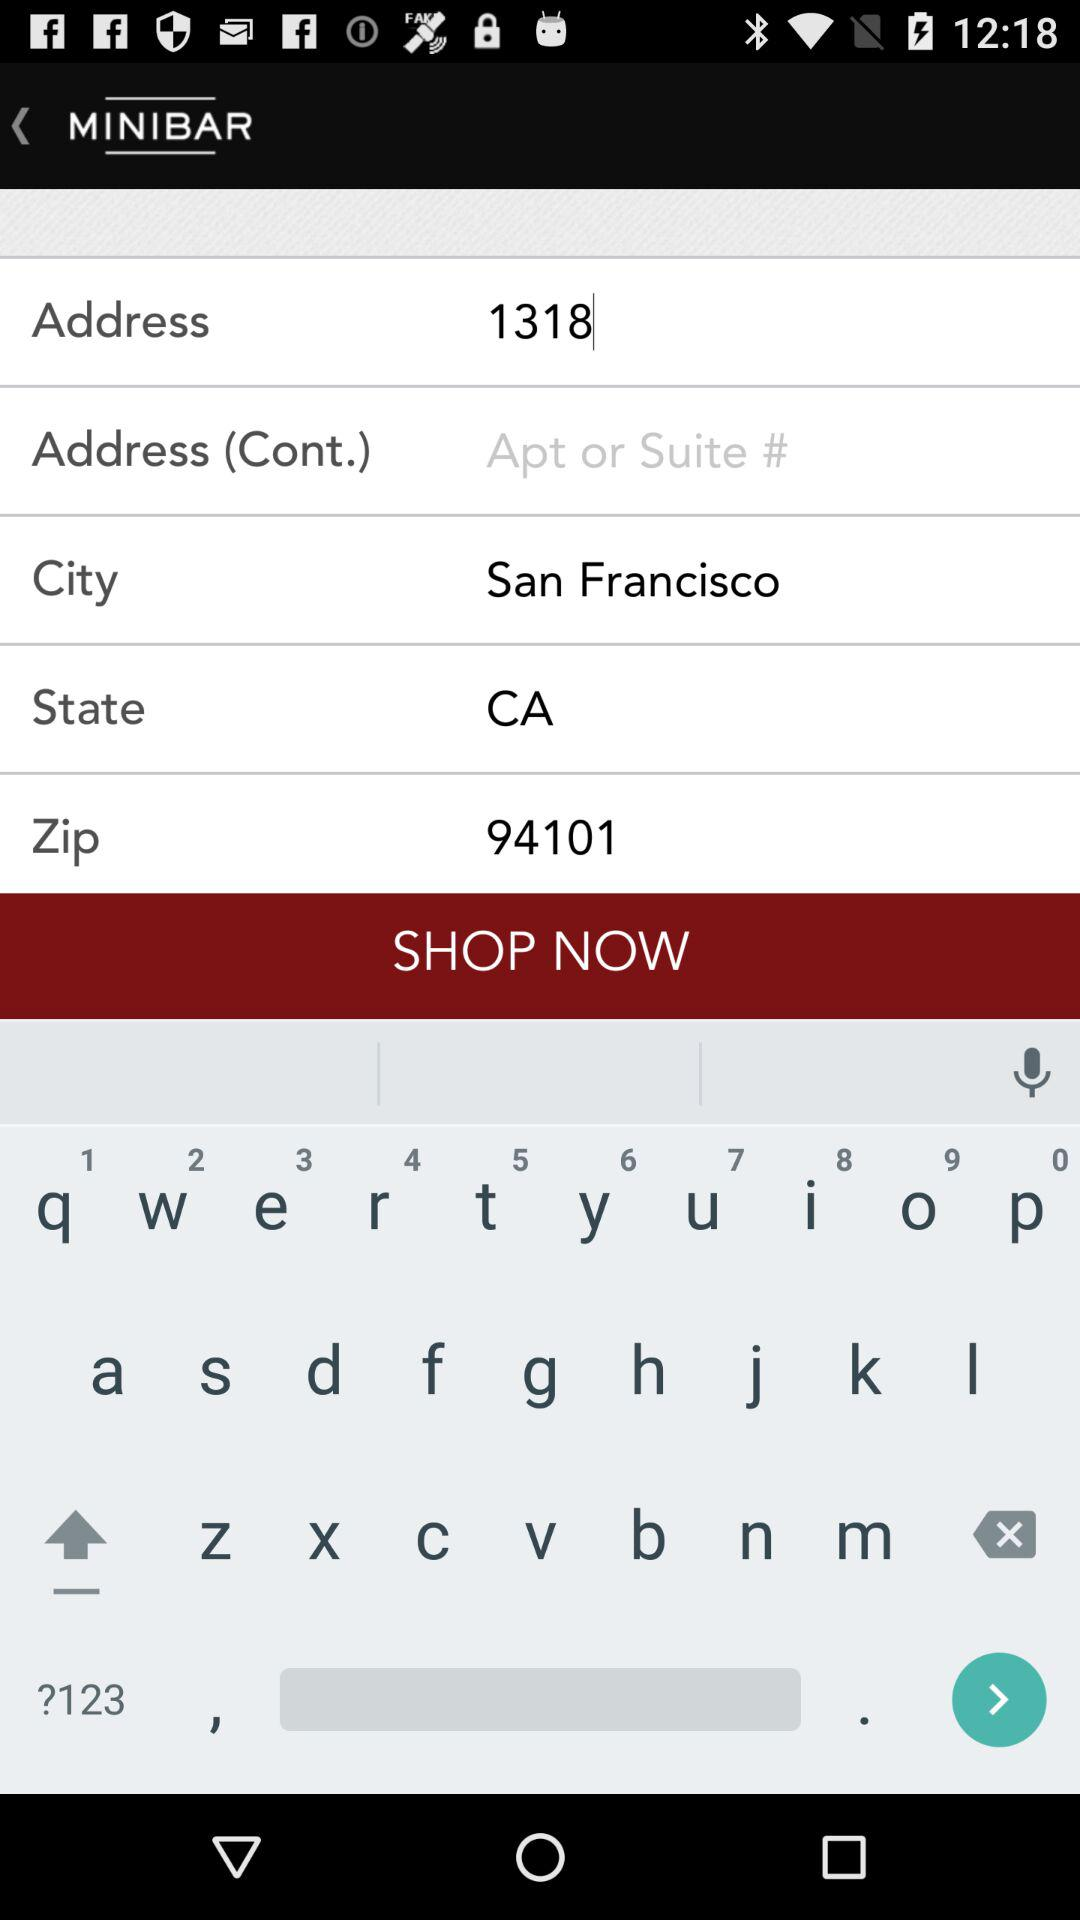What is the zip code? The zip code is 94101. 